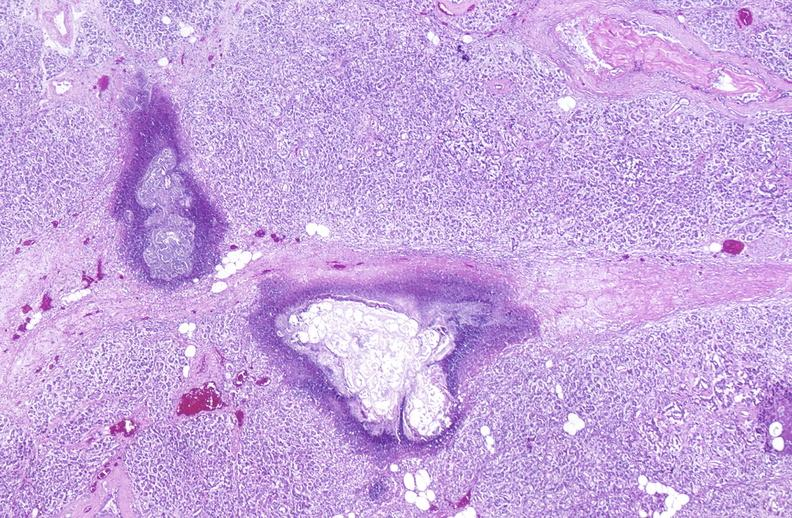does omphalocele show pancreatic fat necrosis?
Answer the question using a single word or phrase. No 